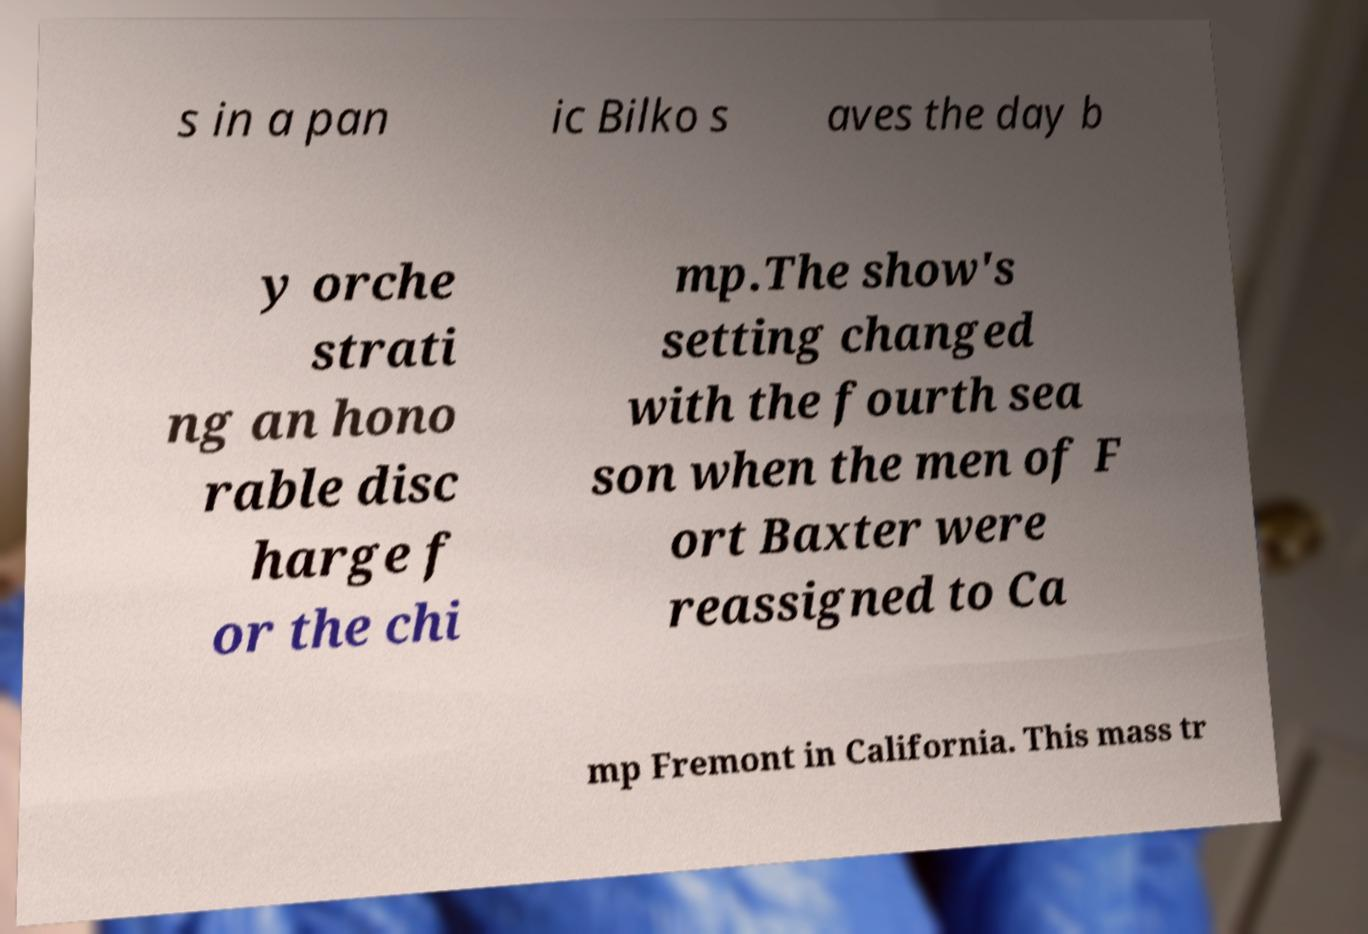Please read and relay the text visible in this image. What does it say? s in a pan ic Bilko s aves the day b y orche strati ng an hono rable disc harge f or the chi mp.The show's setting changed with the fourth sea son when the men of F ort Baxter were reassigned to Ca mp Fremont in California. This mass tr 